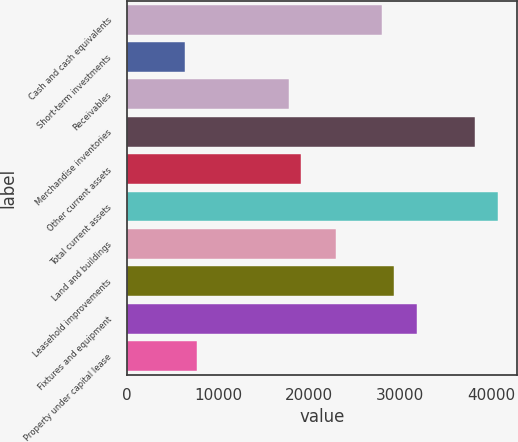Convert chart to OTSL. <chart><loc_0><loc_0><loc_500><loc_500><bar_chart><fcel>Cash and cash equivalents<fcel>Short-term investments<fcel>Receivables<fcel>Merchandise inventories<fcel>Other current assets<fcel>Total current assets<fcel>Land and buildings<fcel>Leasehold improvements<fcel>Fixtures and equipment<fcel>Property under capital lease<nl><fcel>28061.6<fcel>6381.5<fcel>17859.2<fcel>38264<fcel>19134.5<fcel>40814.6<fcel>22960.4<fcel>29336.9<fcel>31887.5<fcel>7656.8<nl></chart> 